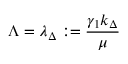Convert formula to latex. <formula><loc_0><loc_0><loc_500><loc_500>\Lambda = \lambda _ { \Delta } \colon = \frac { \gamma _ { 1 } k _ { \Delta } } { \mu }</formula> 